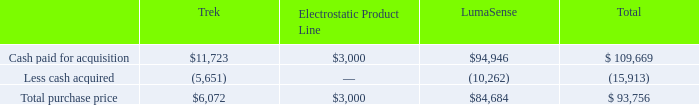ADVANCED ENERGY INDUSTRIES, INC. NOTES TO CONSOLIDATED FINANCIAL STATEMENTS – (continued) (in thousands, except per share amounts)
In February 2018, Advanced Energy acquired Trek Holding Co., LTD ("Trek"), a privately held company with operations in Tokyo, Japan and Lockport, New York, for $6.1 million, net of cash acquired. Trek has a 95% ownership interest in its U.S. subsidiary which is also its primary operation.
The components of the fair value of the total consideration transferred for our 2018 acquisitions are as follows:
What is Trek's ownership interest in its U.S. subsidiary? 95%. What was the fair value of cash paid for acquisition of Trek?
Answer scale should be: thousand. $11,723. What was the fair value of cash paid for acquisition of Lumasense?
Answer scale should be: thousand. $94,946. What was the difference in the fair value of cash paid for acquisition between Trek and Electrostatic Product Line?
Answer scale should be: thousand. $11,723-$3,000
Answer: 8723. What is the sum of the two highest total purchase prices?
Answer scale should be: thousand. $84,684+$6,072
Answer: 90756. What is the average total purchase price amongst the three companies?
Answer scale should be: thousand. ($6,072+$3,000+$84,684)/3
Answer: 31252. 